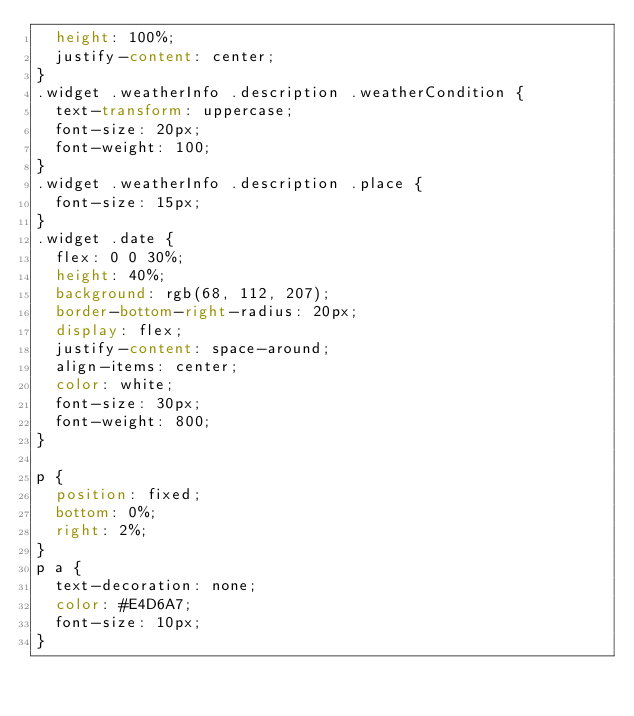<code> <loc_0><loc_0><loc_500><loc_500><_CSS_>  height: 100%;
  justify-content: center;
}
.widget .weatherInfo .description .weatherCondition {
  text-transform: uppercase;
  font-size: 20px;
  font-weight: 100;
}
.widget .weatherInfo .description .place {
  font-size: 15px;
}
.widget .date {
  flex: 0 0 30%;
  height: 40%;
  background: rgb(68, 112, 207);
  border-bottom-right-radius: 20px;
  display: flex;
  justify-content: space-around;
  align-items: center;
  color: white;
  font-size: 30px;
  font-weight: 800;
}

p {
  position: fixed;
  bottom: 0%;
  right: 2%;
}
p a {
  text-decoration: none;
  color: #E4D6A7;
  font-size: 10px;
}
</code> 